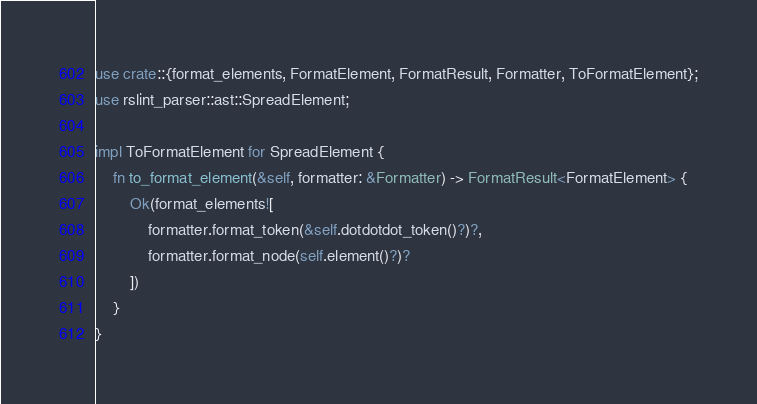Convert code to text. <code><loc_0><loc_0><loc_500><loc_500><_Rust_>use crate::{format_elements, FormatElement, FormatResult, Formatter, ToFormatElement};
use rslint_parser::ast::SpreadElement;

impl ToFormatElement for SpreadElement {
	fn to_format_element(&self, formatter: &Formatter) -> FormatResult<FormatElement> {
		Ok(format_elements![
			formatter.format_token(&self.dotdotdot_token()?)?,
			formatter.format_node(self.element()?)?
		])
	}
}
</code> 